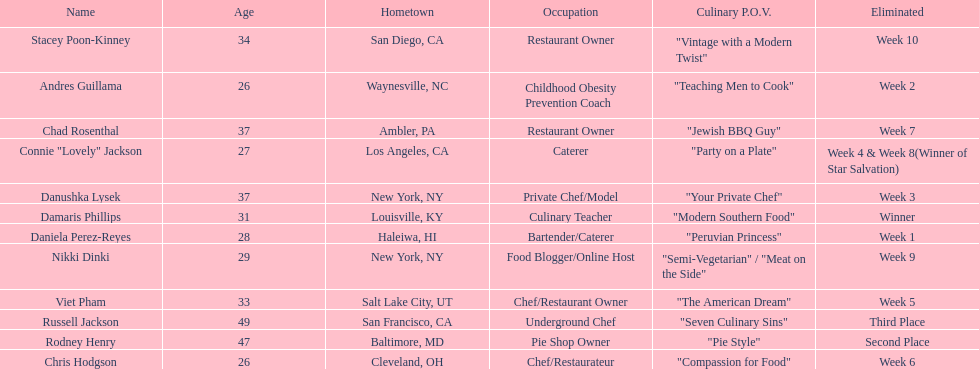Who was the first contestant to be eliminated on season 9 of food network star? Daniela Perez-Reyes. 